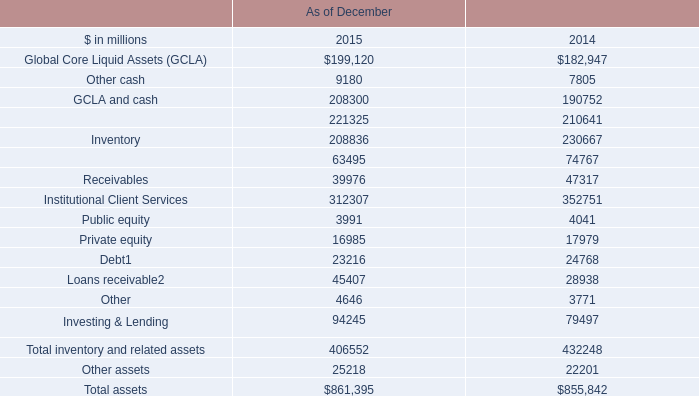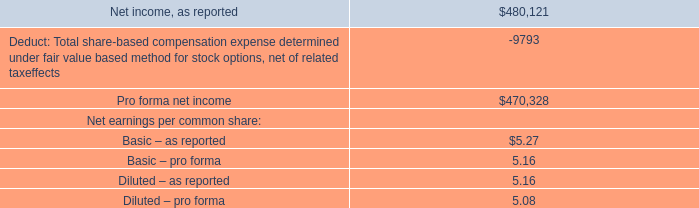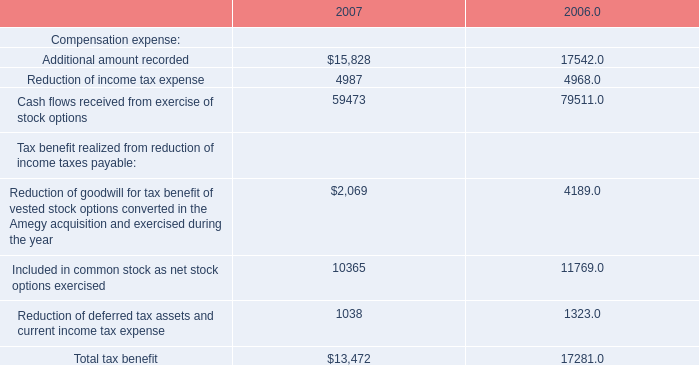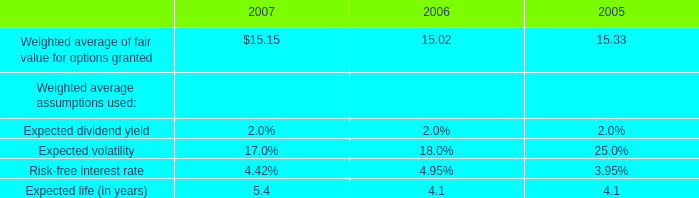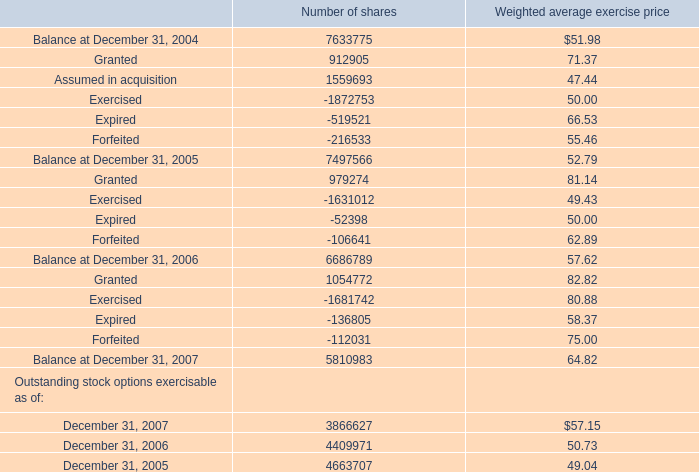What's the current increasing rate of Expired for Number of shares? 
Computations: ((-136805 + 52398) / -52398)
Answer: 1.61088. 